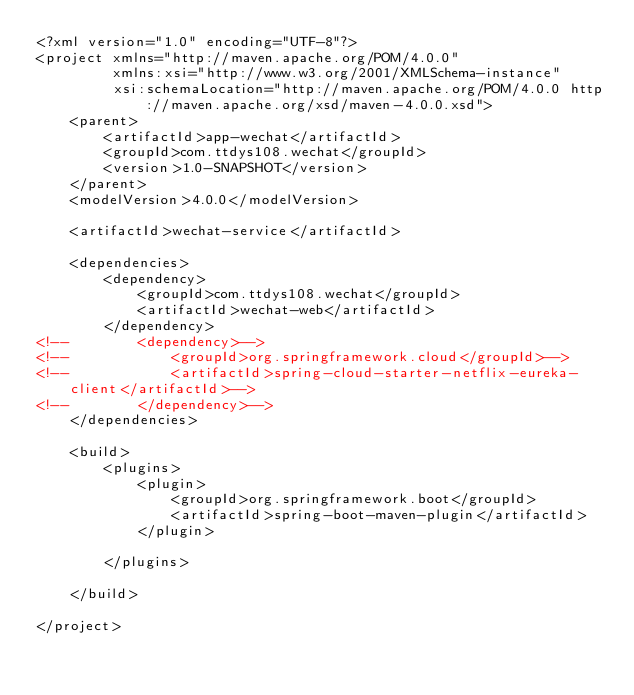<code> <loc_0><loc_0><loc_500><loc_500><_XML_><?xml version="1.0" encoding="UTF-8"?>
<project xmlns="http://maven.apache.org/POM/4.0.0"
         xmlns:xsi="http://www.w3.org/2001/XMLSchema-instance"
         xsi:schemaLocation="http://maven.apache.org/POM/4.0.0 http://maven.apache.org/xsd/maven-4.0.0.xsd">
    <parent>
        <artifactId>app-wechat</artifactId>
        <groupId>com.ttdys108.wechat</groupId>
        <version>1.0-SNAPSHOT</version>
    </parent>
    <modelVersion>4.0.0</modelVersion>

    <artifactId>wechat-service</artifactId>

    <dependencies>
        <dependency>
            <groupId>com.ttdys108.wechat</groupId>
            <artifactId>wechat-web</artifactId>
        </dependency>
<!--        <dependency>-->
<!--            <groupId>org.springframework.cloud</groupId>-->
<!--            <artifactId>spring-cloud-starter-netflix-eureka-client</artifactId>-->
<!--        </dependency>-->
    </dependencies>

    <build>
        <plugins>
            <plugin>
                <groupId>org.springframework.boot</groupId>
                <artifactId>spring-boot-maven-plugin</artifactId>
            </plugin>

        </plugins>

    </build>

</project></code> 